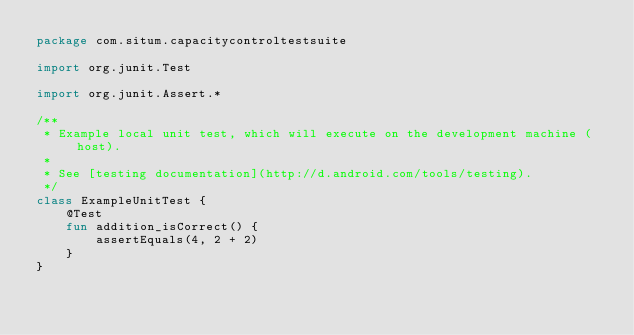<code> <loc_0><loc_0><loc_500><loc_500><_Kotlin_>package com.situm.capacitycontroltestsuite

import org.junit.Test

import org.junit.Assert.*

/**
 * Example local unit test, which will execute on the development machine (host).
 *
 * See [testing documentation](http://d.android.com/tools/testing).
 */
class ExampleUnitTest {
    @Test
    fun addition_isCorrect() {
        assertEquals(4, 2 + 2)
    }
}</code> 